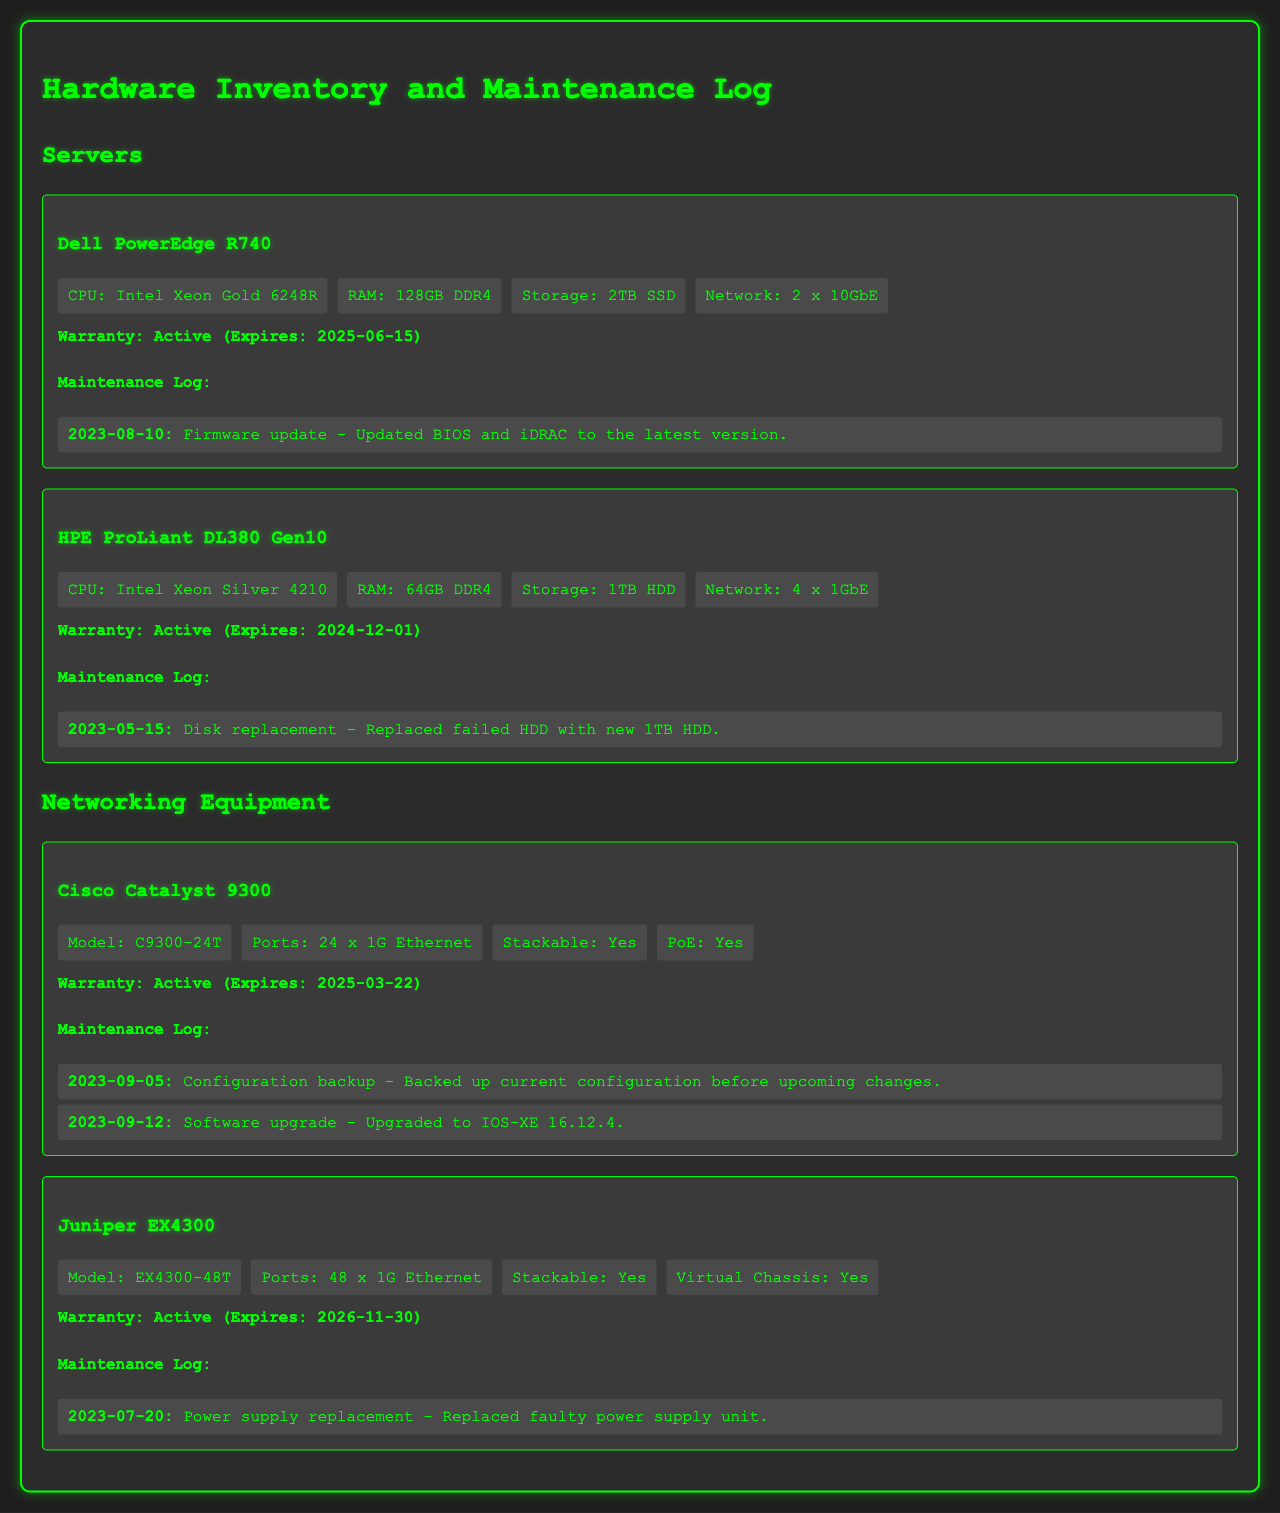What is the CPU model for the Dell PowerEdge R740? The document specifies the CPU model as Intel Xeon Gold 6248R under the Dell PowerEdge R740 section.
Answer: Intel Xeon Gold 6248R When does the warranty for the HPE ProLiant DL380 Gen10 expire? The expiration date for the warranty of the HPE ProLiant DL380 Gen10 is given as 2024-12-01 in the document.
Answer: 2024-12-01 What maintenance activity was performed on the Cisco Catalyst 9300 on September 12, 2023? The document states that a software upgrade was carried out on September 12, 2023, for the Cisco Catalyst 9300.
Answer: Software upgrade How much RAM does the Juniper EX4300 have? The document does not specify RAM for networking equipment; it only provides specifications related to model and ports. This question demonstrates reasoning through the lack of data.
Answer: Not specified Which server has the largest storage capacity? Comparing the storage specifications listed in the document, the Dell PowerEdge R740 has the largest storage capacity of 2TB SSD.
Answer: 2TB SSD How many ports does the Cisco Catalyst 9300 have? The document explicitly states that the Cisco Catalyst 9300 has 24 x 1G Ethernet ports.
Answer: 24 x 1G Ethernet What type of maintenance activity was logged for the HPE ProLiant DL380 Gen10? The maintenance activity logged is a disk replacement for the HPE ProLiant DL380 Gen10.
Answer: Disk replacement Is the warranty status for the Juniper EX4300 active? The document confirms that the warranty status for the Juniper EX4300 is active.
Answer: Active 